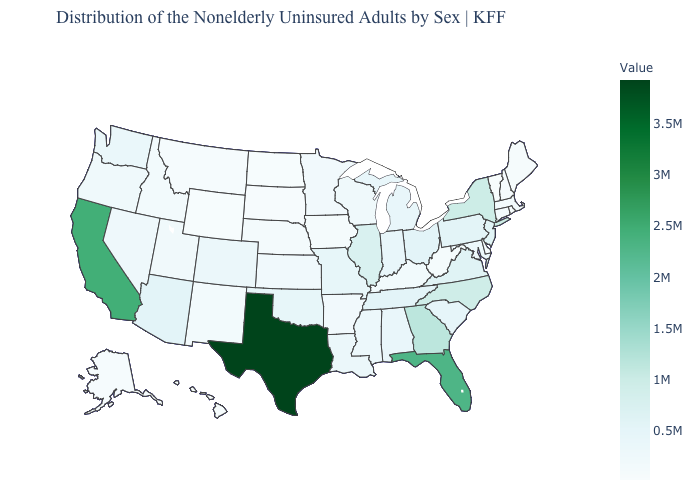Which states have the lowest value in the USA?
Quick response, please. Vermont. Does Hawaii have the lowest value in the West?
Short answer required. Yes. Among the states that border Utah , does Colorado have the lowest value?
Be succinct. No. Does the map have missing data?
Concise answer only. No. Among the states that border Rhode Island , does Connecticut have the lowest value?
Answer briefly. No. Which states hav the highest value in the West?
Give a very brief answer. California. Which states have the highest value in the USA?
Write a very short answer. Texas. Does Missouri have a lower value than North Carolina?
Be succinct. Yes. Does Illinois have the highest value in the MidWest?
Keep it brief. Yes. Among the states that border Connecticut , which have the lowest value?
Write a very short answer. Rhode Island. Among the states that border Texas , does Arkansas have the lowest value?
Quick response, please. No. 